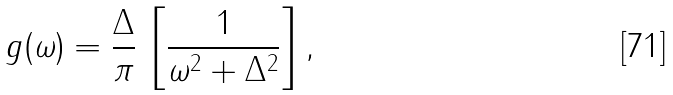Convert formula to latex. <formula><loc_0><loc_0><loc_500><loc_500>g ( \omega ) = \frac { \Delta } { \pi } \, \left [ \frac { 1 } { \omega ^ { 2 } + \Delta ^ { 2 } } \right ] ,</formula> 